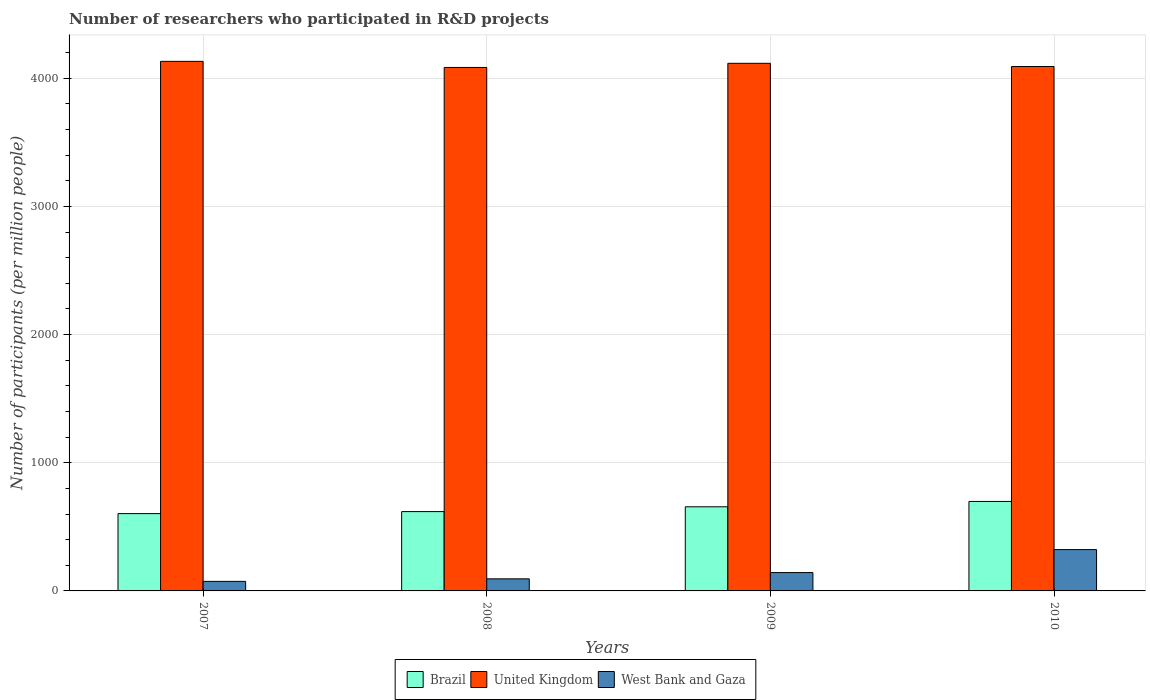How many groups of bars are there?
Ensure brevity in your answer.  4. How many bars are there on the 1st tick from the left?
Your answer should be compact. 3. How many bars are there on the 2nd tick from the right?
Ensure brevity in your answer.  3. What is the label of the 4th group of bars from the left?
Give a very brief answer. 2010. What is the number of researchers who participated in R&D projects in United Kingdom in 2010?
Give a very brief answer. 4091.18. Across all years, what is the maximum number of researchers who participated in R&D projects in United Kingdom?
Offer a very short reply. 4131.53. Across all years, what is the minimum number of researchers who participated in R&D projects in Brazil?
Your answer should be compact. 603.11. In which year was the number of researchers who participated in R&D projects in Brazil maximum?
Your response must be concise. 2010. What is the total number of researchers who participated in R&D projects in West Bank and Gaza in the graph?
Give a very brief answer. 634.38. What is the difference between the number of researchers who participated in R&D projects in West Bank and Gaza in 2007 and that in 2009?
Your response must be concise. -68.61. What is the difference between the number of researchers who participated in R&D projects in Brazil in 2008 and the number of researchers who participated in R&D projects in West Bank and Gaza in 2010?
Offer a terse response. 296.37. What is the average number of researchers who participated in R&D projects in United Kingdom per year?
Make the answer very short. 4105.73. In the year 2010, what is the difference between the number of researchers who participated in R&D projects in United Kingdom and number of researchers who participated in R&D projects in Brazil?
Your answer should be very brief. 3393.07. In how many years, is the number of researchers who participated in R&D projects in Brazil greater than 1400?
Offer a very short reply. 0. What is the ratio of the number of researchers who participated in R&D projects in West Bank and Gaza in 2009 to that in 2010?
Offer a terse response. 0.44. Is the difference between the number of researchers who participated in R&D projects in United Kingdom in 2008 and 2009 greater than the difference between the number of researchers who participated in R&D projects in Brazil in 2008 and 2009?
Your answer should be compact. Yes. What is the difference between the highest and the second highest number of researchers who participated in R&D projects in Brazil?
Ensure brevity in your answer.  41.77. What is the difference between the highest and the lowest number of researchers who participated in R&D projects in Brazil?
Offer a very short reply. 94.99. What does the 2nd bar from the right in 2007 represents?
Make the answer very short. United Kingdom. Is it the case that in every year, the sum of the number of researchers who participated in R&D projects in West Bank and Gaza and number of researchers who participated in R&D projects in Brazil is greater than the number of researchers who participated in R&D projects in United Kingdom?
Provide a short and direct response. No. How many bars are there?
Keep it short and to the point. 12. Does the graph contain grids?
Make the answer very short. Yes. Where does the legend appear in the graph?
Your answer should be compact. Bottom center. What is the title of the graph?
Make the answer very short. Number of researchers who participated in R&D projects. What is the label or title of the Y-axis?
Provide a short and direct response. Number of participants (per million people). What is the Number of participants (per million people) of Brazil in 2007?
Make the answer very short. 603.11. What is the Number of participants (per million people) in United Kingdom in 2007?
Keep it short and to the point. 4131.53. What is the Number of participants (per million people) of West Bank and Gaza in 2007?
Offer a terse response. 74.57. What is the Number of participants (per million people) in Brazil in 2008?
Provide a short and direct response. 618.83. What is the Number of participants (per million people) of United Kingdom in 2008?
Your answer should be very brief. 4083.86. What is the Number of participants (per million people) in West Bank and Gaza in 2008?
Provide a succinct answer. 94.17. What is the Number of participants (per million people) in Brazil in 2009?
Provide a succinct answer. 656.34. What is the Number of participants (per million people) in United Kingdom in 2009?
Offer a very short reply. 4116.35. What is the Number of participants (per million people) in West Bank and Gaza in 2009?
Your answer should be compact. 143.18. What is the Number of participants (per million people) of Brazil in 2010?
Make the answer very short. 698.1. What is the Number of participants (per million people) of United Kingdom in 2010?
Give a very brief answer. 4091.18. What is the Number of participants (per million people) of West Bank and Gaza in 2010?
Your answer should be very brief. 322.46. Across all years, what is the maximum Number of participants (per million people) in Brazil?
Ensure brevity in your answer.  698.1. Across all years, what is the maximum Number of participants (per million people) in United Kingdom?
Provide a succinct answer. 4131.53. Across all years, what is the maximum Number of participants (per million people) in West Bank and Gaza?
Make the answer very short. 322.46. Across all years, what is the minimum Number of participants (per million people) of Brazil?
Keep it short and to the point. 603.11. Across all years, what is the minimum Number of participants (per million people) of United Kingdom?
Offer a terse response. 4083.86. Across all years, what is the minimum Number of participants (per million people) of West Bank and Gaza?
Your answer should be very brief. 74.57. What is the total Number of participants (per million people) of Brazil in the graph?
Provide a short and direct response. 2576.37. What is the total Number of participants (per million people) of United Kingdom in the graph?
Ensure brevity in your answer.  1.64e+04. What is the total Number of participants (per million people) in West Bank and Gaza in the graph?
Your answer should be compact. 634.38. What is the difference between the Number of participants (per million people) in Brazil in 2007 and that in 2008?
Offer a terse response. -15.72. What is the difference between the Number of participants (per million people) in United Kingdom in 2007 and that in 2008?
Make the answer very short. 47.67. What is the difference between the Number of participants (per million people) in West Bank and Gaza in 2007 and that in 2008?
Make the answer very short. -19.6. What is the difference between the Number of participants (per million people) of Brazil in 2007 and that in 2009?
Your answer should be very brief. -53.23. What is the difference between the Number of participants (per million people) of United Kingdom in 2007 and that in 2009?
Your answer should be very brief. 15.18. What is the difference between the Number of participants (per million people) in West Bank and Gaza in 2007 and that in 2009?
Make the answer very short. -68.61. What is the difference between the Number of participants (per million people) in Brazil in 2007 and that in 2010?
Provide a succinct answer. -94.99. What is the difference between the Number of participants (per million people) of United Kingdom in 2007 and that in 2010?
Provide a succinct answer. 40.36. What is the difference between the Number of participants (per million people) in West Bank and Gaza in 2007 and that in 2010?
Your response must be concise. -247.88. What is the difference between the Number of participants (per million people) in Brazil in 2008 and that in 2009?
Your answer should be very brief. -37.51. What is the difference between the Number of participants (per million people) of United Kingdom in 2008 and that in 2009?
Provide a succinct answer. -32.49. What is the difference between the Number of participants (per million people) of West Bank and Gaza in 2008 and that in 2009?
Your answer should be compact. -49.01. What is the difference between the Number of participants (per million people) in Brazil in 2008 and that in 2010?
Provide a succinct answer. -79.27. What is the difference between the Number of participants (per million people) in United Kingdom in 2008 and that in 2010?
Your answer should be very brief. -7.32. What is the difference between the Number of participants (per million people) in West Bank and Gaza in 2008 and that in 2010?
Your answer should be compact. -228.28. What is the difference between the Number of participants (per million people) of Brazil in 2009 and that in 2010?
Your answer should be compact. -41.77. What is the difference between the Number of participants (per million people) of United Kingdom in 2009 and that in 2010?
Your answer should be very brief. 25.17. What is the difference between the Number of participants (per million people) in West Bank and Gaza in 2009 and that in 2010?
Offer a very short reply. -179.27. What is the difference between the Number of participants (per million people) in Brazil in 2007 and the Number of participants (per million people) in United Kingdom in 2008?
Give a very brief answer. -3480.75. What is the difference between the Number of participants (per million people) in Brazil in 2007 and the Number of participants (per million people) in West Bank and Gaza in 2008?
Your answer should be very brief. 508.94. What is the difference between the Number of participants (per million people) of United Kingdom in 2007 and the Number of participants (per million people) of West Bank and Gaza in 2008?
Offer a terse response. 4037.36. What is the difference between the Number of participants (per million people) in Brazil in 2007 and the Number of participants (per million people) in United Kingdom in 2009?
Offer a terse response. -3513.24. What is the difference between the Number of participants (per million people) of Brazil in 2007 and the Number of participants (per million people) of West Bank and Gaza in 2009?
Offer a terse response. 459.93. What is the difference between the Number of participants (per million people) in United Kingdom in 2007 and the Number of participants (per million people) in West Bank and Gaza in 2009?
Ensure brevity in your answer.  3988.35. What is the difference between the Number of participants (per million people) of Brazil in 2007 and the Number of participants (per million people) of United Kingdom in 2010?
Give a very brief answer. -3488.07. What is the difference between the Number of participants (per million people) of Brazil in 2007 and the Number of participants (per million people) of West Bank and Gaza in 2010?
Make the answer very short. 280.65. What is the difference between the Number of participants (per million people) in United Kingdom in 2007 and the Number of participants (per million people) in West Bank and Gaza in 2010?
Offer a terse response. 3809.08. What is the difference between the Number of participants (per million people) in Brazil in 2008 and the Number of participants (per million people) in United Kingdom in 2009?
Provide a succinct answer. -3497.52. What is the difference between the Number of participants (per million people) in Brazil in 2008 and the Number of participants (per million people) in West Bank and Gaza in 2009?
Offer a terse response. 475.65. What is the difference between the Number of participants (per million people) in United Kingdom in 2008 and the Number of participants (per million people) in West Bank and Gaza in 2009?
Ensure brevity in your answer.  3940.68. What is the difference between the Number of participants (per million people) in Brazil in 2008 and the Number of participants (per million people) in United Kingdom in 2010?
Offer a terse response. -3472.35. What is the difference between the Number of participants (per million people) in Brazil in 2008 and the Number of participants (per million people) in West Bank and Gaza in 2010?
Provide a succinct answer. 296.37. What is the difference between the Number of participants (per million people) in United Kingdom in 2008 and the Number of participants (per million people) in West Bank and Gaza in 2010?
Provide a succinct answer. 3761.4. What is the difference between the Number of participants (per million people) in Brazil in 2009 and the Number of participants (per million people) in United Kingdom in 2010?
Keep it short and to the point. -3434.84. What is the difference between the Number of participants (per million people) of Brazil in 2009 and the Number of participants (per million people) of West Bank and Gaza in 2010?
Give a very brief answer. 333.88. What is the difference between the Number of participants (per million people) of United Kingdom in 2009 and the Number of participants (per million people) of West Bank and Gaza in 2010?
Keep it short and to the point. 3793.89. What is the average Number of participants (per million people) of Brazil per year?
Your answer should be compact. 644.09. What is the average Number of participants (per million people) in United Kingdom per year?
Offer a terse response. 4105.73. What is the average Number of participants (per million people) in West Bank and Gaza per year?
Ensure brevity in your answer.  158.6. In the year 2007, what is the difference between the Number of participants (per million people) in Brazil and Number of participants (per million people) in United Kingdom?
Your answer should be compact. -3528.43. In the year 2007, what is the difference between the Number of participants (per million people) of Brazil and Number of participants (per million people) of West Bank and Gaza?
Your answer should be compact. 528.54. In the year 2007, what is the difference between the Number of participants (per million people) in United Kingdom and Number of participants (per million people) in West Bank and Gaza?
Provide a succinct answer. 4056.96. In the year 2008, what is the difference between the Number of participants (per million people) in Brazil and Number of participants (per million people) in United Kingdom?
Your response must be concise. -3465.03. In the year 2008, what is the difference between the Number of participants (per million people) in Brazil and Number of participants (per million people) in West Bank and Gaza?
Make the answer very short. 524.66. In the year 2008, what is the difference between the Number of participants (per million people) in United Kingdom and Number of participants (per million people) in West Bank and Gaza?
Offer a terse response. 3989.69. In the year 2009, what is the difference between the Number of participants (per million people) of Brazil and Number of participants (per million people) of United Kingdom?
Your answer should be very brief. -3460.02. In the year 2009, what is the difference between the Number of participants (per million people) of Brazil and Number of participants (per million people) of West Bank and Gaza?
Offer a very short reply. 513.15. In the year 2009, what is the difference between the Number of participants (per million people) of United Kingdom and Number of participants (per million people) of West Bank and Gaza?
Give a very brief answer. 3973.17. In the year 2010, what is the difference between the Number of participants (per million people) in Brazil and Number of participants (per million people) in United Kingdom?
Make the answer very short. -3393.07. In the year 2010, what is the difference between the Number of participants (per million people) in Brazil and Number of participants (per million people) in West Bank and Gaza?
Give a very brief answer. 375.65. In the year 2010, what is the difference between the Number of participants (per million people) in United Kingdom and Number of participants (per million people) in West Bank and Gaza?
Make the answer very short. 3768.72. What is the ratio of the Number of participants (per million people) of Brazil in 2007 to that in 2008?
Ensure brevity in your answer.  0.97. What is the ratio of the Number of participants (per million people) of United Kingdom in 2007 to that in 2008?
Provide a succinct answer. 1.01. What is the ratio of the Number of participants (per million people) in West Bank and Gaza in 2007 to that in 2008?
Provide a succinct answer. 0.79. What is the ratio of the Number of participants (per million people) of Brazil in 2007 to that in 2009?
Ensure brevity in your answer.  0.92. What is the ratio of the Number of participants (per million people) of United Kingdom in 2007 to that in 2009?
Offer a very short reply. 1. What is the ratio of the Number of participants (per million people) of West Bank and Gaza in 2007 to that in 2009?
Keep it short and to the point. 0.52. What is the ratio of the Number of participants (per million people) in Brazil in 2007 to that in 2010?
Ensure brevity in your answer.  0.86. What is the ratio of the Number of participants (per million people) in United Kingdom in 2007 to that in 2010?
Make the answer very short. 1.01. What is the ratio of the Number of participants (per million people) of West Bank and Gaza in 2007 to that in 2010?
Make the answer very short. 0.23. What is the ratio of the Number of participants (per million people) of Brazil in 2008 to that in 2009?
Ensure brevity in your answer.  0.94. What is the ratio of the Number of participants (per million people) of West Bank and Gaza in 2008 to that in 2009?
Offer a terse response. 0.66. What is the ratio of the Number of participants (per million people) in Brazil in 2008 to that in 2010?
Keep it short and to the point. 0.89. What is the ratio of the Number of participants (per million people) of West Bank and Gaza in 2008 to that in 2010?
Provide a succinct answer. 0.29. What is the ratio of the Number of participants (per million people) of Brazil in 2009 to that in 2010?
Keep it short and to the point. 0.94. What is the ratio of the Number of participants (per million people) in West Bank and Gaza in 2009 to that in 2010?
Your response must be concise. 0.44. What is the difference between the highest and the second highest Number of participants (per million people) in Brazil?
Offer a very short reply. 41.77. What is the difference between the highest and the second highest Number of participants (per million people) in United Kingdom?
Your answer should be compact. 15.18. What is the difference between the highest and the second highest Number of participants (per million people) of West Bank and Gaza?
Offer a terse response. 179.27. What is the difference between the highest and the lowest Number of participants (per million people) of Brazil?
Provide a succinct answer. 94.99. What is the difference between the highest and the lowest Number of participants (per million people) in United Kingdom?
Keep it short and to the point. 47.67. What is the difference between the highest and the lowest Number of participants (per million people) of West Bank and Gaza?
Give a very brief answer. 247.88. 